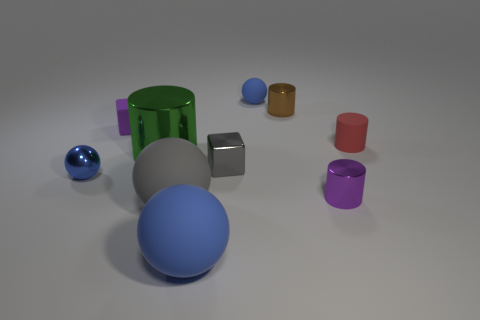How many blue spheres must be subtracted to get 1 blue spheres? 2 Subtract all red blocks. How many blue spheres are left? 3 Subtract all cylinders. How many objects are left? 6 Add 6 big rubber balls. How many big rubber balls exist? 8 Subtract 0 cyan cubes. How many objects are left? 10 Subtract all small metallic things. Subtract all brown things. How many objects are left? 5 Add 7 tiny balls. How many tiny balls are left? 9 